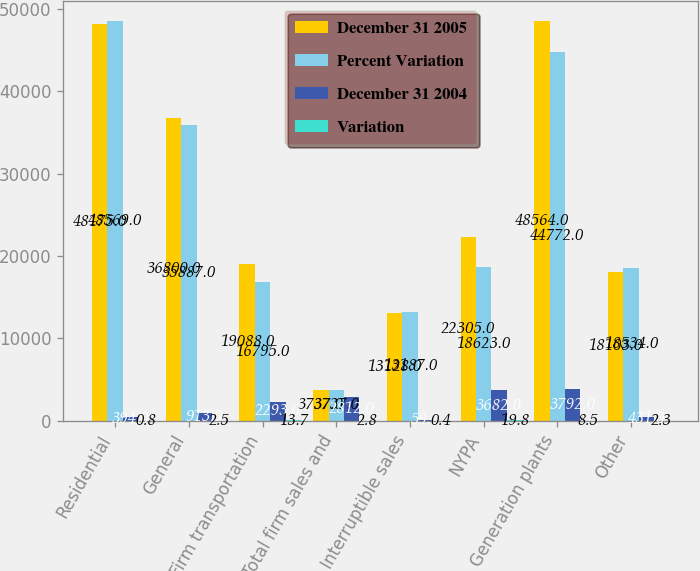<chart> <loc_0><loc_0><loc_500><loc_500><stacked_bar_chart><ecel><fcel>Residential<fcel>General<fcel>Firm transportation<fcel>Total firm sales and<fcel>Interruptible sales<fcel>NYPA<fcel>Generation plants<fcel>Other<nl><fcel>December 31 2005<fcel>48175<fcel>36800<fcel>19088<fcel>3737<fcel>13128<fcel>22305<fcel>48564<fcel>18103<nl><fcel>Percent Variation<fcel>48569<fcel>35887<fcel>16795<fcel>3737<fcel>13187<fcel>18623<fcel>44772<fcel>18534<nl><fcel>December 31 2004<fcel>394<fcel>913<fcel>2293<fcel>2812<fcel>59<fcel>3682<fcel>3792<fcel>431<nl><fcel>Variation<fcel>0.8<fcel>2.5<fcel>13.7<fcel>2.8<fcel>0.4<fcel>19.8<fcel>8.5<fcel>2.3<nl></chart> 